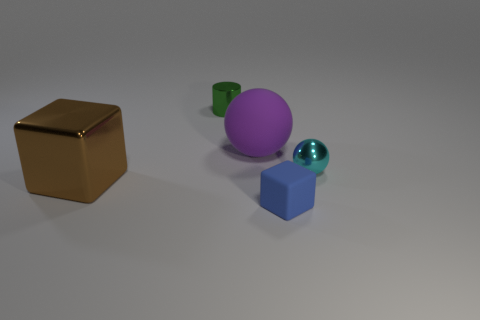There is a small metallic object in front of the purple thing; does it have the same shape as the large brown thing?
Your answer should be compact. No. How many tiny rubber blocks are right of the rubber thing in front of the big object in front of the cyan object?
Provide a succinct answer. 0. Is the number of brown metallic cubes right of the small block less than the number of rubber spheres behind the green object?
Provide a short and direct response. No. What color is the other thing that is the same shape as the purple matte object?
Make the answer very short. Cyan. How big is the green cylinder?
Your answer should be very brief. Small. What number of other purple matte things have the same size as the purple rubber thing?
Your response must be concise. 0. Is the matte sphere the same color as the big metal cube?
Your response must be concise. No. Is the material of the cyan sphere that is in front of the green cylinder the same as the cube that is to the left of the small rubber object?
Provide a succinct answer. Yes. Is the number of tiny cyan metallic cylinders greater than the number of green metallic objects?
Give a very brief answer. No. Are there any other things that have the same color as the tiny ball?
Offer a terse response. No. 